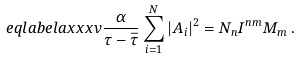<formula> <loc_0><loc_0><loc_500><loc_500>\ e q l a b e l { a x x x v } \frac { \alpha } { \tau - \bar { \tau } } \sum _ { i = 1 } ^ { N } | A _ { i } | ^ { 2 } = N _ { n } { I } ^ { n m } M _ { m } \, .</formula> 